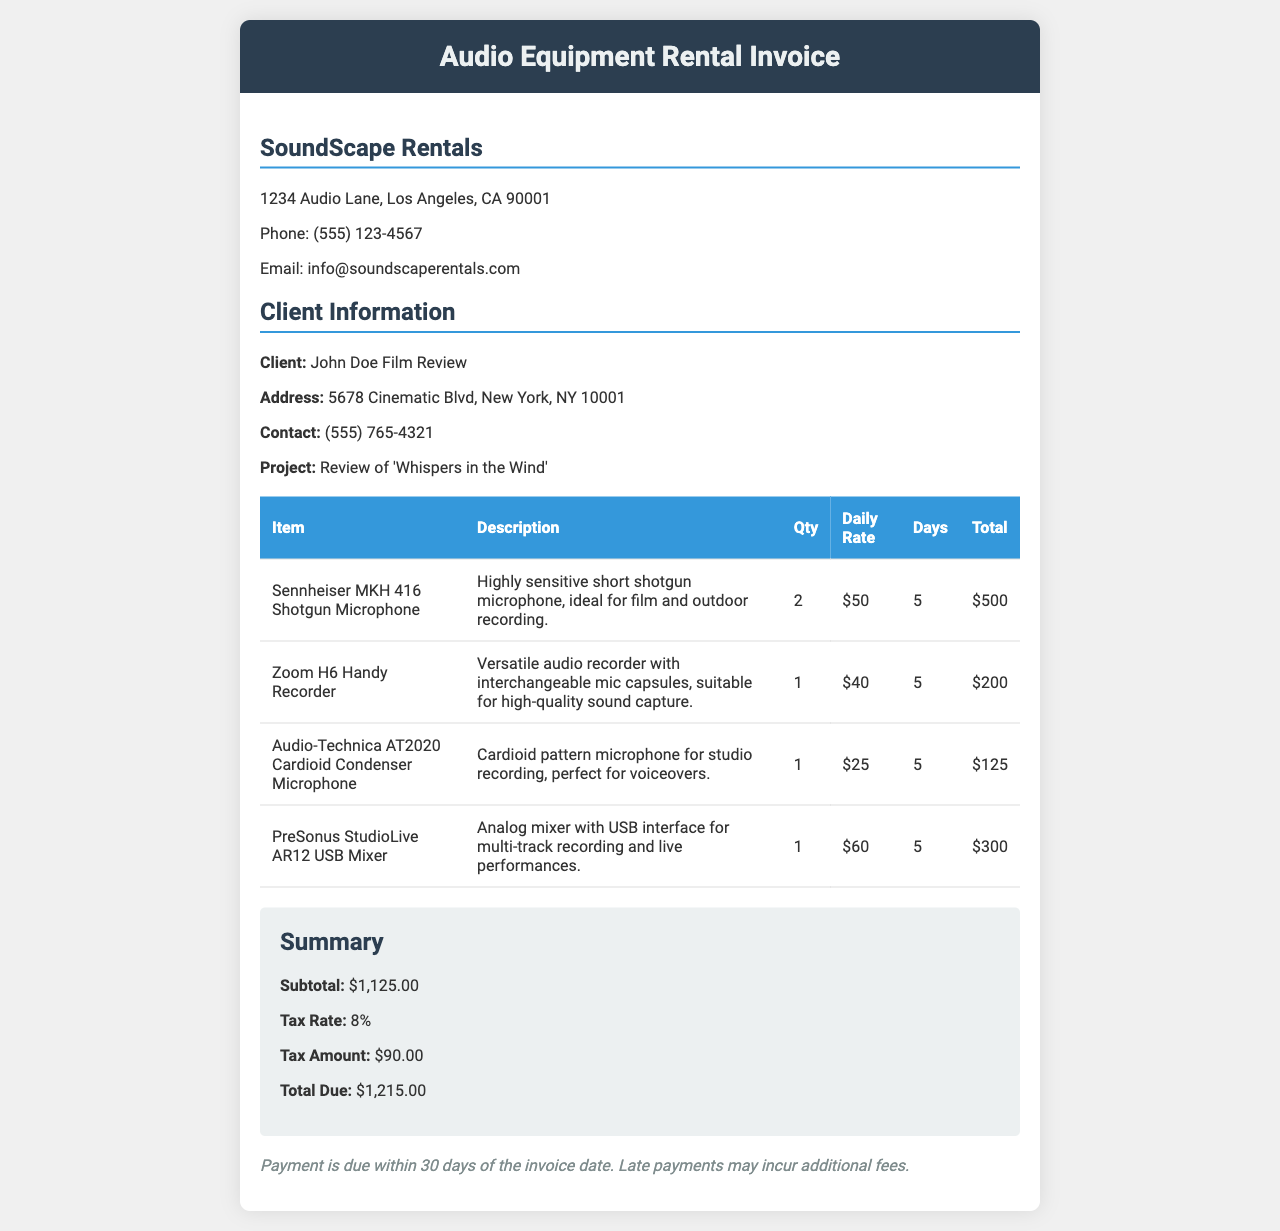What is the total due amount? The total due amount is listed in the summary section of the invoice.
Answer: $1,215.00 Who is the client? The client's name is mentioned in the client information section of the invoice.
Answer: John Doe Film Review What is the quantity of the Sennheiser MKH 416 Shotgun Microphone? The quantity of Sennheiser MKH 416 Shotgun Microphone is stated in the equipment table.
Answer: 2 What is the daily rate for the Audio-Technica AT2020 Cardioid Condenser Microphone? The daily rate for the Audio-Technica AT2020 is given in the table with other equipment costs.
Answer: $25 How many days was the equipment rented for? The rental period is specified in the equipment table for each item.
Answer: 5 What is the tax amount? The tax amount is provided in the summary section.
Answer: $90.00 Which company provided the rental services? The company providing the rental services is mentioned at the beginning of the invoice.
Answer: SoundScape Rentals What is the total for the Zoom H6 Handy Recorder? The total amount for the Zoom H6 Handy Recorder is calculated based on the daily rate and days rented, mentioned in the table.
Answer: $200.00 What is the address of the client? The address for the client is mentioned in the client information section of the invoice.
Answer: 5678 Cinematic Blvd, New York, NY 10001 